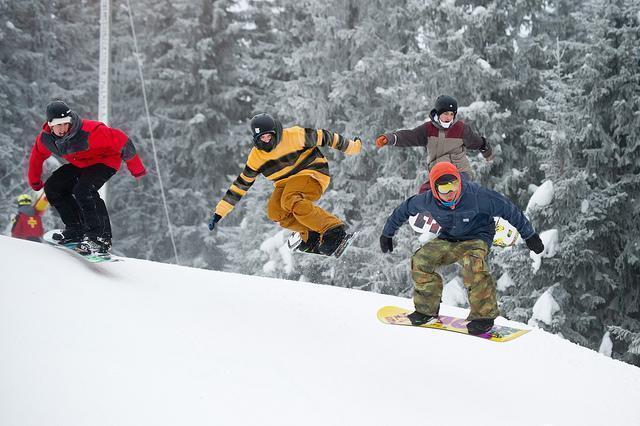The middle athlete looks like an what?
Select the accurate answer and provide explanation: 'Answer: answer
Rationale: rationale.'
Options: Shark, dog, bee, horse. Answer: bee.
Rationale: He has a striped shirt on that is yellow and black. 